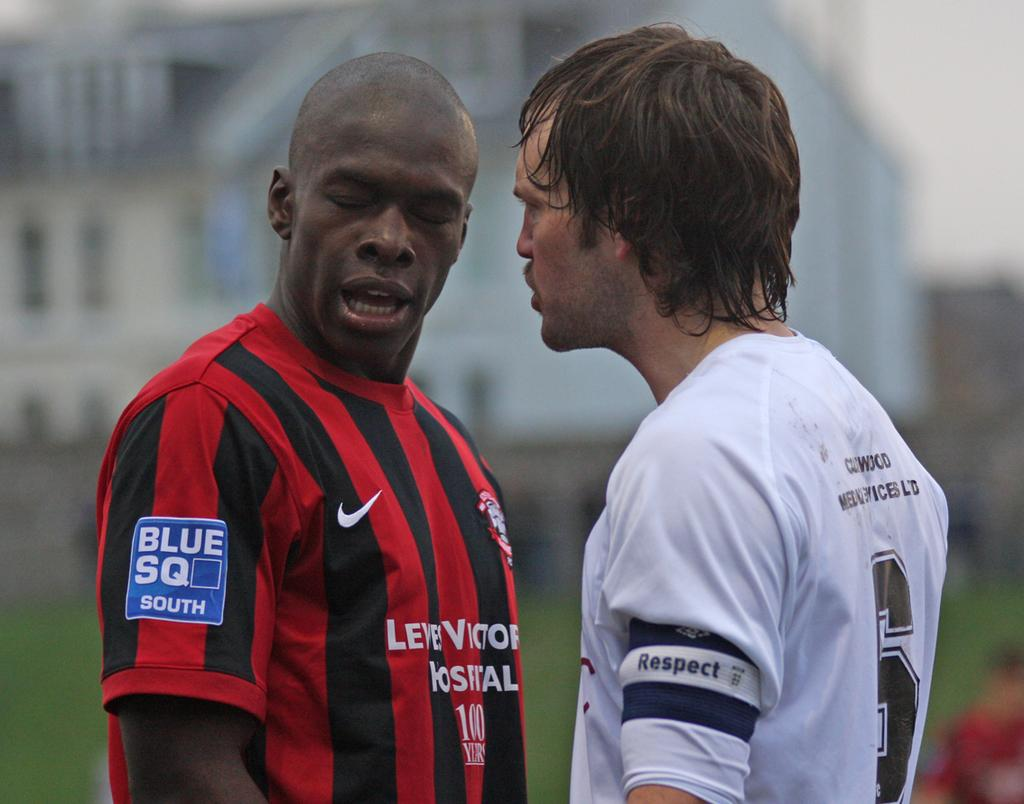<image>
Render a clear and concise summary of the photo. The patch on an athlete's striped uniform reads BLUE SQ SOUTH. 